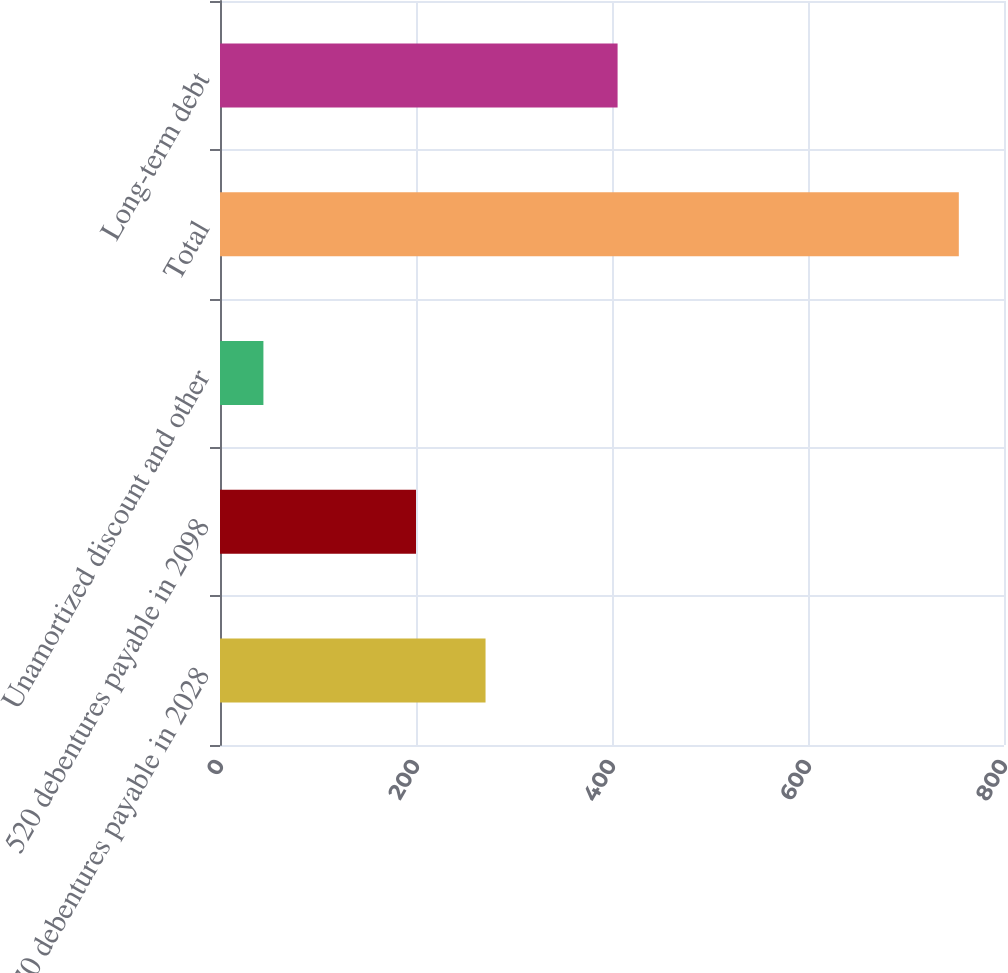Convert chart to OTSL. <chart><loc_0><loc_0><loc_500><loc_500><bar_chart><fcel>670 debentures payable in 2028<fcel>520 debentures payable in 2098<fcel>Unamortized discount and other<fcel>Total<fcel>Long-term debt<nl><fcel>270.96<fcel>200<fcel>44.3<fcel>753.9<fcel>405.7<nl></chart> 